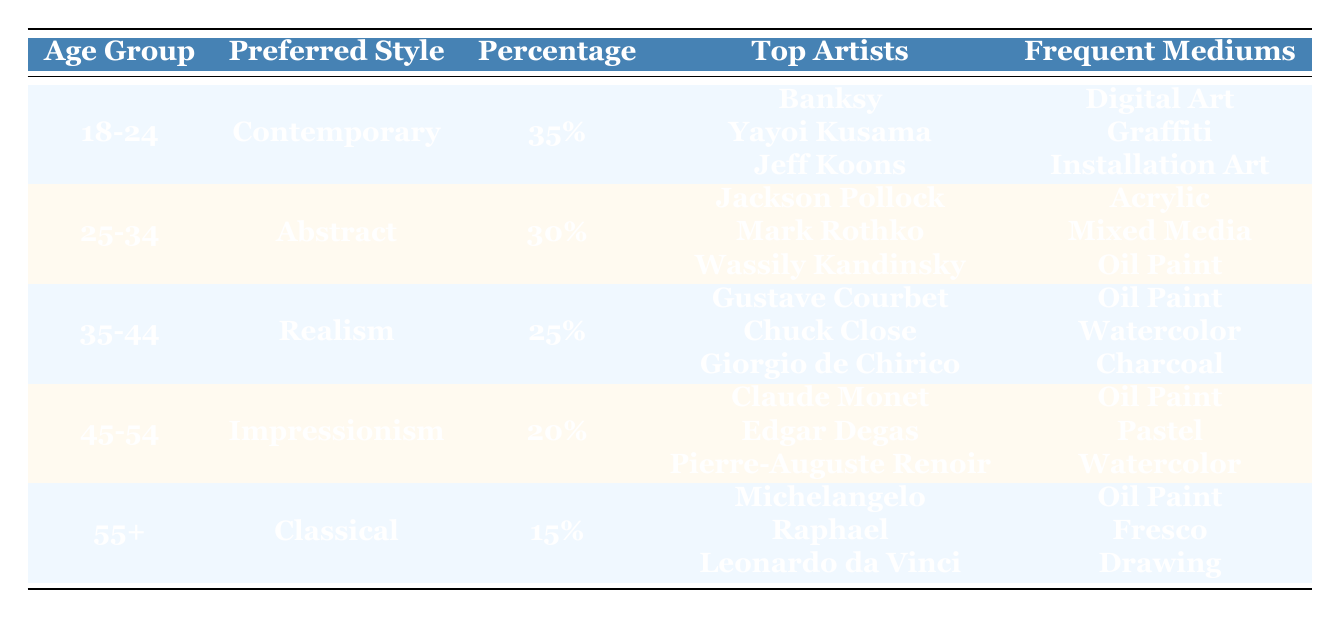What is the preferred art style of the 18-24 age group? According to the table, the preferred art style for the age group 18-24 is listed under the "Preferred Style" column, where it states "Contemporary."
Answer: Contemporary Which age group has the highest percentage of preferred art style? Looking at the "Percentage" column, the highest percentage is 35% for the age group 18-24.
Answer: 18-24 What are the top artists for the 25-34 age group? The "Top Artists" column for the age group 25-34 includes Jackson Pollock, Mark Rothko, and Wassily Kandinsky.
Answer: Jackson Pollock, Mark Rothko, Wassily Kandinsky Is the preferred art style of the 55+ age group Classical? In the "Preferred Style" column, the age group 55+ is listed as having a preferred style of "Classical," so this statement is true.
Answer: Yes What is the difference in percentage between the preferred art styles of the 25-34 and 35-44 age groups? The percentage for the 25-34 age group is 30%, and for the 35-44 age group, it is 25%. The difference is calculated as 30 - 25 = 5.
Answer: 5 Which age group has the lowest percentage for preferred art style, and what is it? The age group 55+ has the lowest percentage of 15% for the preferred art style, which is listed in the "Percentage" column.
Answer: 55+, 15% What are the frequent mediums for the age group 45-54? For the age group 45-54, the "Frequent Mediums" column indicates that they commonly use Oil Paint, Pastel, and Watercolor.
Answer: Oil Paint, Pastel, Watercolor What is the average percentage of preferred art styles for all age groups combined? The percentages are 35, 30, 25, 20, and 15. The sum is 35 + 30 + 25 + 20 + 15 = 125, and there are 5 age groups, so the average is 125/5 = 25.
Answer: 25 Which age group prefers Digital Art most frequently? The "Frequent Mediums" column associated with the 18-24 age group lists Digital Art as one of the mediums, making it the only age group indicating this medium as frequent.
Answer: 18-24 